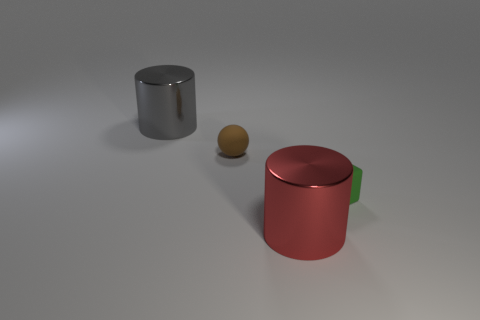Add 3 big gray objects. How many objects exist? 7 Subtract all spheres. How many objects are left? 3 Subtract all small blue things. Subtract all shiny objects. How many objects are left? 2 Add 3 green things. How many green things are left? 4 Add 1 tiny cyan rubber cylinders. How many tiny cyan rubber cylinders exist? 1 Subtract 1 brown spheres. How many objects are left? 3 